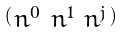Convert formula to latex. <formula><loc_0><loc_0><loc_500><loc_500>\begin{psmallmatrix} n ^ { 0 } & n ^ { 1 } & n ^ { j } \end{psmallmatrix}</formula> 